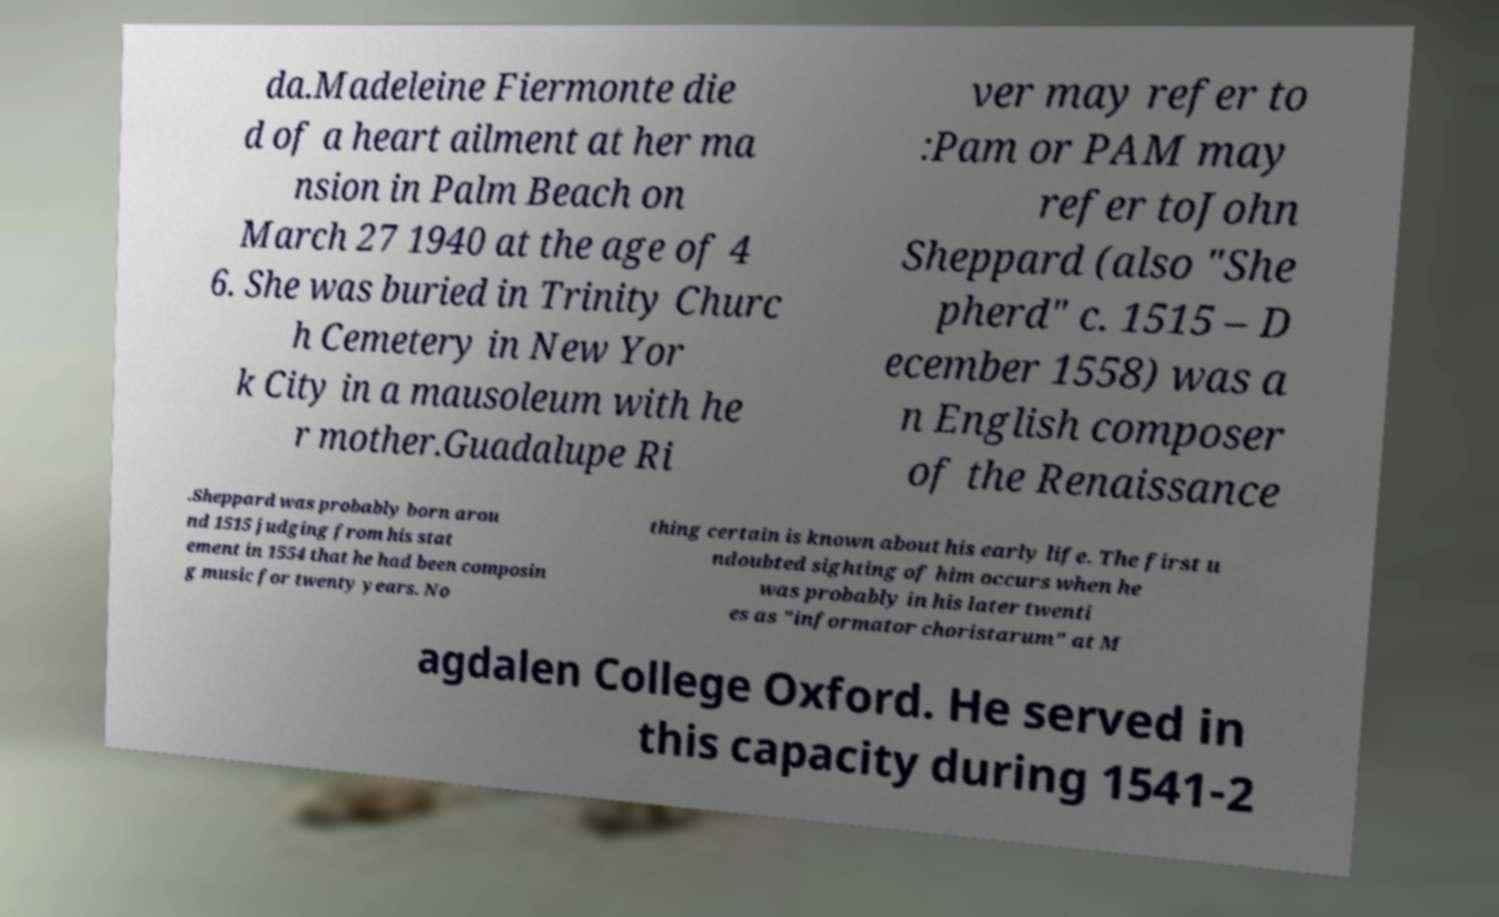What messages or text are displayed in this image? I need them in a readable, typed format. da.Madeleine Fiermonte die d of a heart ailment at her ma nsion in Palm Beach on March 27 1940 at the age of 4 6. She was buried in Trinity Churc h Cemetery in New Yor k City in a mausoleum with he r mother.Guadalupe Ri ver may refer to :Pam or PAM may refer toJohn Sheppard (also "She pherd" c. 1515 – D ecember 1558) was a n English composer of the Renaissance .Sheppard was probably born arou nd 1515 judging from his stat ement in 1554 that he had been composin g music for twenty years. No thing certain is known about his early life. The first u ndoubted sighting of him occurs when he was probably in his later twenti es as "informator choristarum" at M agdalen College Oxford. He served in this capacity during 1541-2 